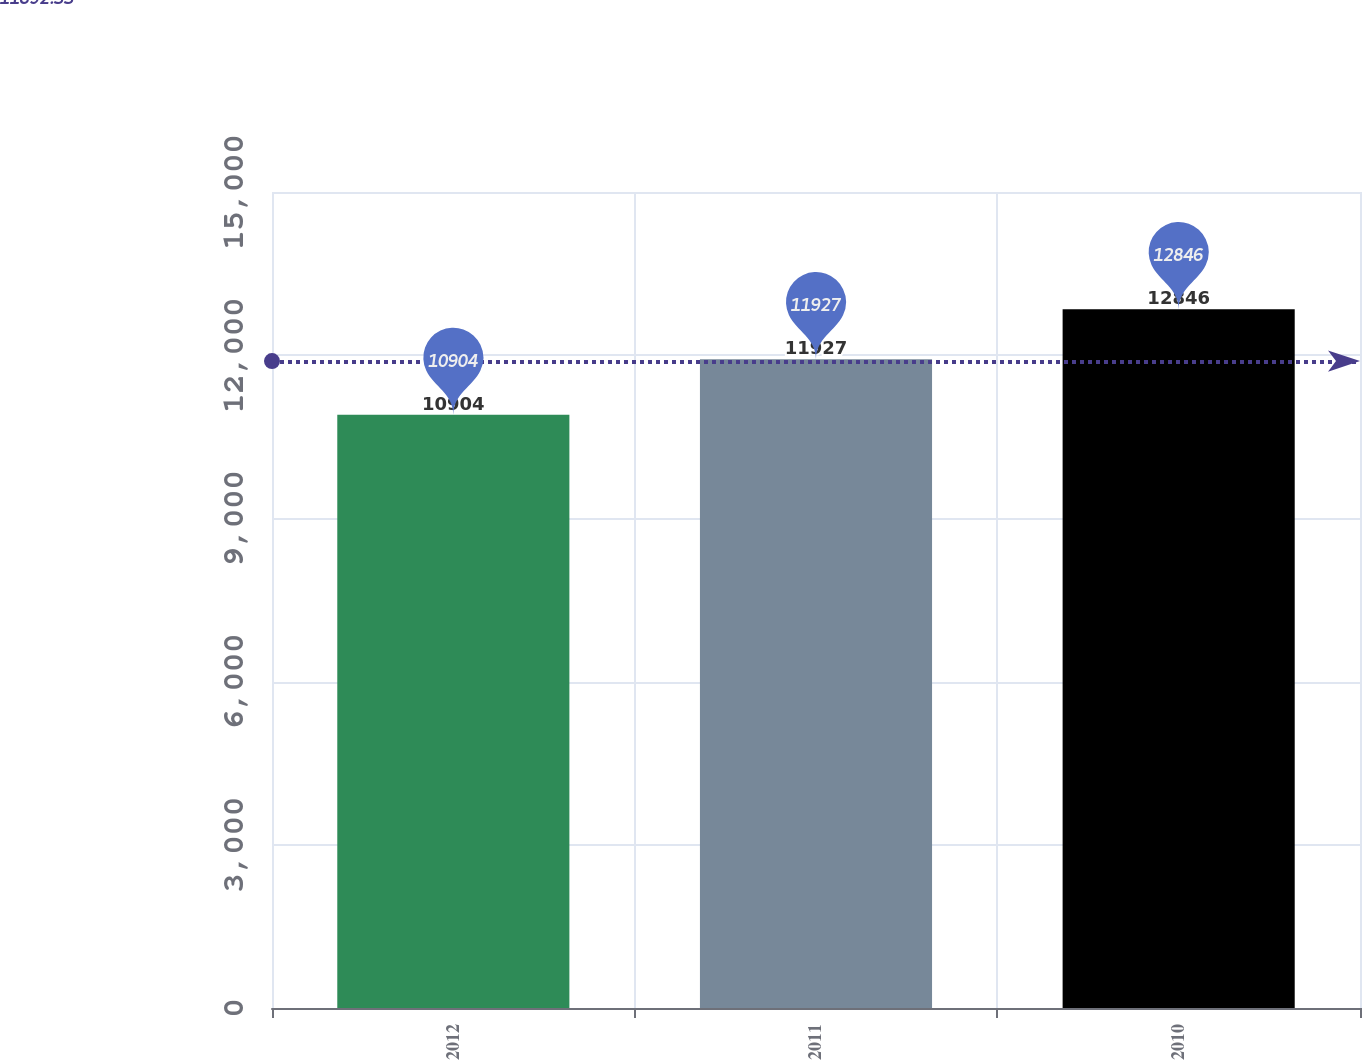<chart> <loc_0><loc_0><loc_500><loc_500><bar_chart><fcel>2012<fcel>2011<fcel>2010<nl><fcel>10904<fcel>11927<fcel>12846<nl></chart> 